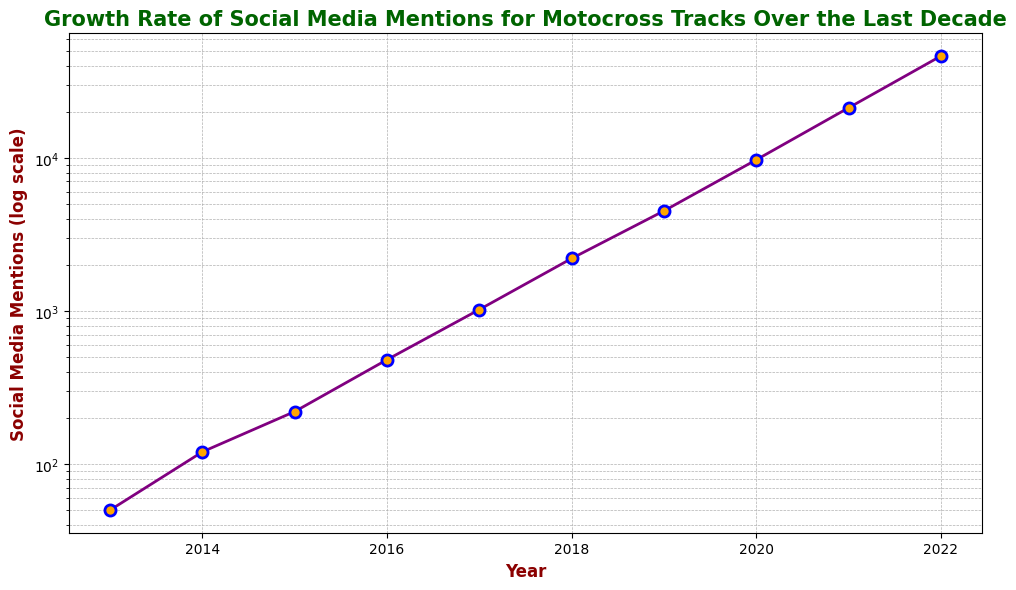What's the difference in social media mentions between 2015 and 2020? To find the difference, subtract the number of mentions in 2015 from the mentions in 2020. The values are 9700 (2020) and 220 (2015). So, 9700 - 220 = 9480.
Answer: 9480 Which year shows the largest increase in social media mentions compared to the previous year? Compare the increments between consecutive years. The largest increment is between 2019 (4500) and 2020 (9700), which is 9700 - 4500 = 5200.
Answer: 2020 What is the median number of social media mentions from 2013 to 2022? List the values in ascending order: 50, 120, 220, 480, 1020, 2200, 4500, 9700, 21200, 46200. The median is the average of the 5th and 6th values: (1020 + 2200) / 2 = 1610.
Answer: 1610 By what factor did social media mentions increase from 2017 to 2022? Calculate the ratio of the mentions in 2022 to those in 2017. The values are 46200 (2022) and 1020 (2017). So, 46200 / 1020 ≈ 45.29.
Answer: 45.29 Which color marks the data points on the plot? The plot uses orange to mark the data points. This can be visually observed on the plot.
Answer: Orange From 2019 to 2020, what was the percentage increase in social media mentions? The values are 4500 (2019) and 9700 (2020). Calculate the percentage increase: ((9700 - 4500) / 4500) * 100 ≈ 115.56%.
Answer: 115.56% How many years did it take for social media mentions to increase from 50 to over 4500? Mentions increased from 50 in 2013 to over 4500 in 2019. Calculate the difference in years: 2019 - 2013 = 6 years.
Answer: 6 Are there any years where the number of social media mentions more than doubled compared to the previous year? Compare each year's value with the previous year's double value. In 2014 (120) compared to 2013 (50*2=100) and in 2018 (2200) compared to 2017 (1020*2=2040), the mentions more than doubled.
Answer: Yes, 2014 and 2018 What trend can you observe from the plot? The plot shows an exponential increase in social media mentions over the last decade. The log scale y-axis reveals this consistent year-on-year growth.
Answer: Exponential increase What is the primary color of the line connecting the data points? The line connecting the data points is purple, which is visually evident from the plot.
Answer: Purple 